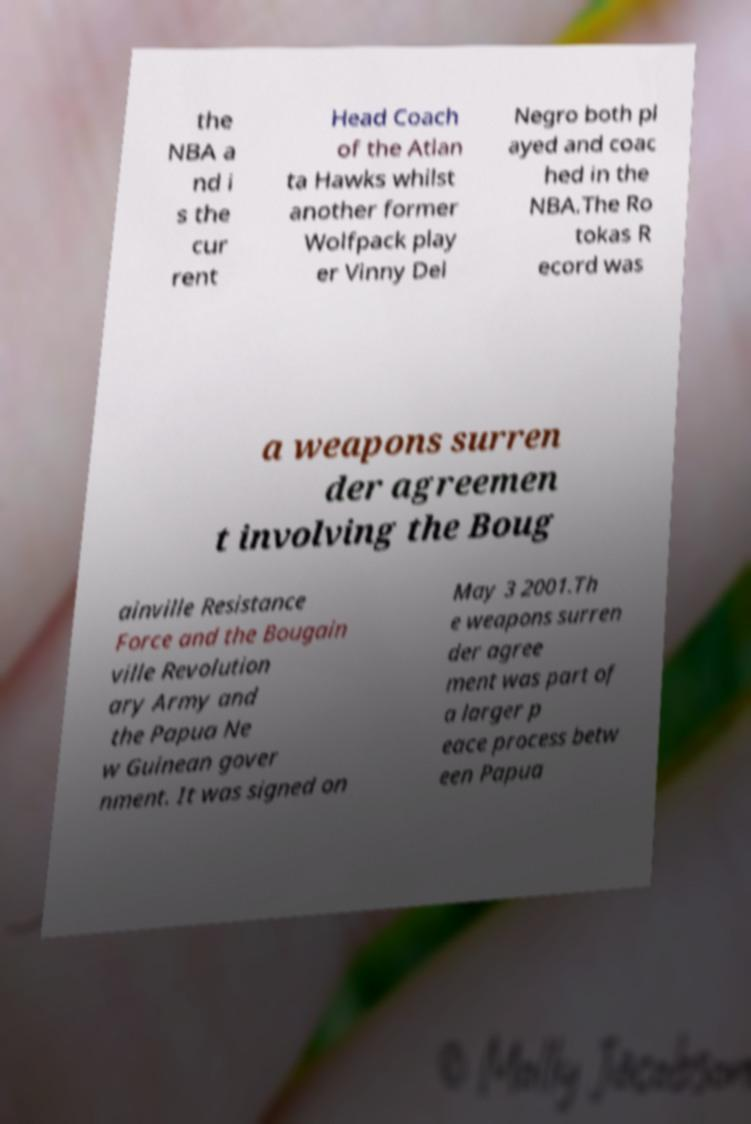For documentation purposes, I need the text within this image transcribed. Could you provide that? the NBA a nd i s the cur rent Head Coach of the Atlan ta Hawks whilst another former Wolfpack play er Vinny Del Negro both pl ayed and coac hed in the NBA.The Ro tokas R ecord was a weapons surren der agreemen t involving the Boug ainville Resistance Force and the Bougain ville Revolution ary Army and the Papua Ne w Guinean gover nment. It was signed on May 3 2001.Th e weapons surren der agree ment was part of a larger p eace process betw een Papua 